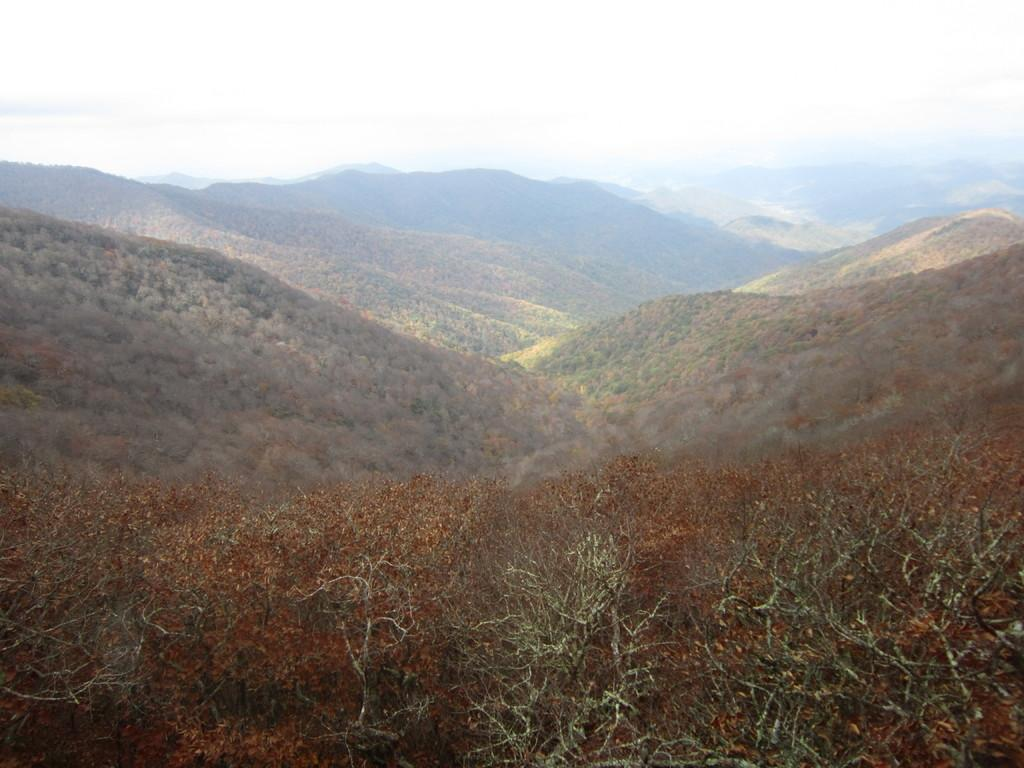What type of landscape is depicted in the image? The image features hills. What is covering the hills in the image? The hills are covered with trees. What is visible at the top of the image? The sky is visible at the top of the image. What type of board can be seen being used by the giants in the image? There are no giants or boards present in the image. 